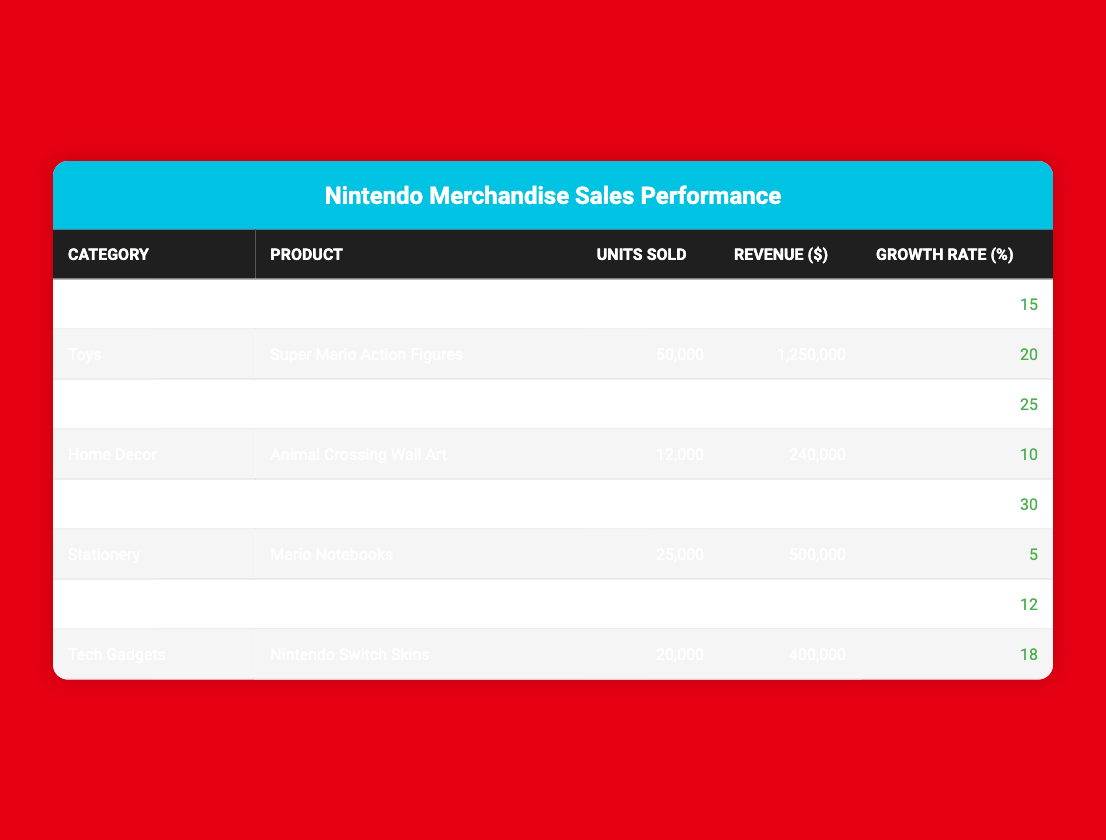What's the total revenue generated from Pokémon Card Packs? The table shows that the revenue from Pokémon Card Packs is $2,250,000.
Answer: $2,250,000 Which product sold the highest number of units? According to the table, Pokémon Card Packs had the highest units sold at 150,000.
Answer: Pokémon Card Packs What is the growth rate of Super Smash Bros. Game Controller? The table indicates that the growth rate for Super Smash Bros. Game Controller is 30%.
Answer: 30% What is the average revenue generated across all merchandise categories? To find the average revenue, we first sum the revenue of all products: ($750,000 + $1,250,000 + $2,250,000 + $240,000 + $800,000 + $500,000 + $160,000 + $400,000 = $6,550,000). Then, we divide by the number of products (8): $6,550,000 / 8 = $818,750.
Answer: $818,750 Did any product have a growth rate below 10%? Yes, the Mario Notebooks had a growth rate of 5%, which is below 10%.
Answer: Yes What is the combined units sold for Technical Gadgets and Home Goods? Technical Gadgets sold 20,000 units and Home Goods sold 8,000 units. Adding them together: 20,000 + 8,000 = 28,000 units.
Answer: 28,000 Which category had the lowest revenue and how much was it? The Home Goods category had the lowest revenue at $160,000 as seen in the table.
Answer: $160,000 If we consider only the categories with a growth rate above 15%, what is their total revenue? The growth rates above 15% are for Gaming Accessories (30%), Collectibles (25%), and Toys (20%). Their revenues are $800,000, $2,250,000, and $1,250,000 respectively. Adding them: $800,000 + $2,250,000 + $1,250,000 = $4,300,000.
Answer: $4,300,000 What is the difference in units sold between the top-selling product and the lowest-selling product? The top-selling product is Pokémon Card Packs with 150,000 units, while the lowest is the Pokémon-themed Bedding Set with 8,000 units. The difference is 150,000 - 8,000 = 142,000 units.
Answer: 142,000 Did any product in the Home Decor category sell more than 10,000 units? No, the only product in Home Decor, Animal Crossing Wall Art, sold 12,000 units, which is more than 10,000.
Answer: Yes 